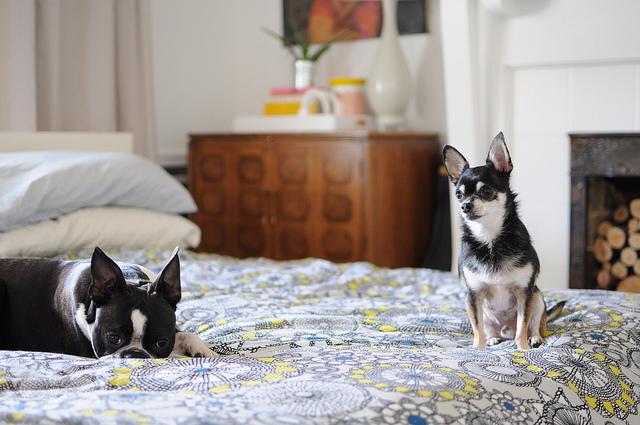What is the dog on the right staring at?
Give a very brief answer. Other dog. How many pillows are on the bed?
Quick response, please. 2. How many dogs are on the bed?
Answer briefly. 2. 